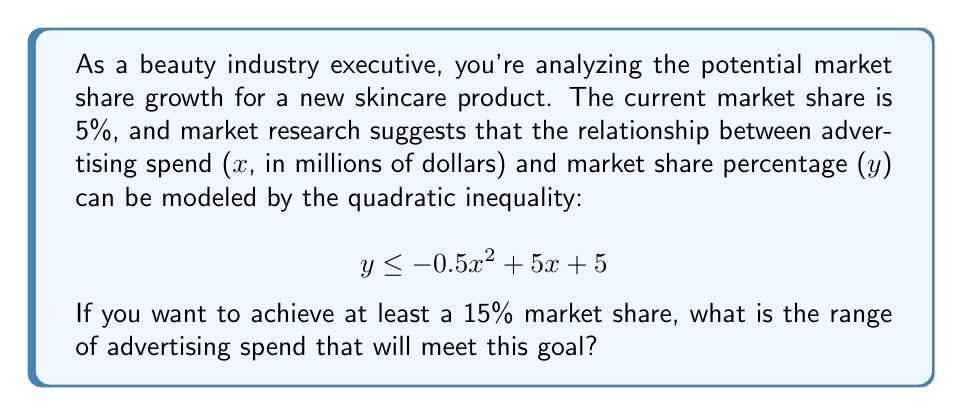Help me with this question. To solve this problem, we need to follow these steps:

1) We want to find the range of x (advertising spend) where y (market share) is at least 15%. This can be expressed as:

   $$ 15 \leq -0.5x^2 + 5x + 5 $$

2) Rearrange the inequality:

   $$ 0 \leq -0.5x^2 + 5x - 10 $$

3) This is a quadratic inequality. To solve it, we first need to find the roots of the quadratic equation:

   $$ -0.5x^2 + 5x - 10 = 0 $$

4) We can solve this using the quadratic formula: $x = \frac{-b \pm \sqrt{b^2 - 4ac}}{2a}$

   Where $a = -0.5$, $b = 5$, and $c = -10$

5) Plugging these values into the quadratic formula:

   $$ x = \frac{-5 \pm \sqrt{5^2 - 4(-0.5)(-10)}}{2(-0.5)} = \frac{-5 \pm \sqrt{25 - 20}}{-1} = \frac{-5 \pm \sqrt{5}}{-1} $$

6) Simplifying:

   $$ x = 5 \pm \sqrt{5} $$

7) Therefore, the roots are:

   $$ x_1 = 5 + \sqrt{5} \approx 7.24 $$
   $$ x_2 = 5 - \sqrt{5} \approx 2.76 $$

8) The parabola opens downward because the coefficient of $x^2$ is negative. This means the inequality is satisfied between these two roots.

Therefore, to achieve at least a 15% market share, the advertising spend should be between $2.76 million and $7.24 million.
Answer: The range of advertising spend to achieve at least a 15% market share is:

$$ 2.76 \leq x \leq 7.24 $$

where x is in millions of dollars. 